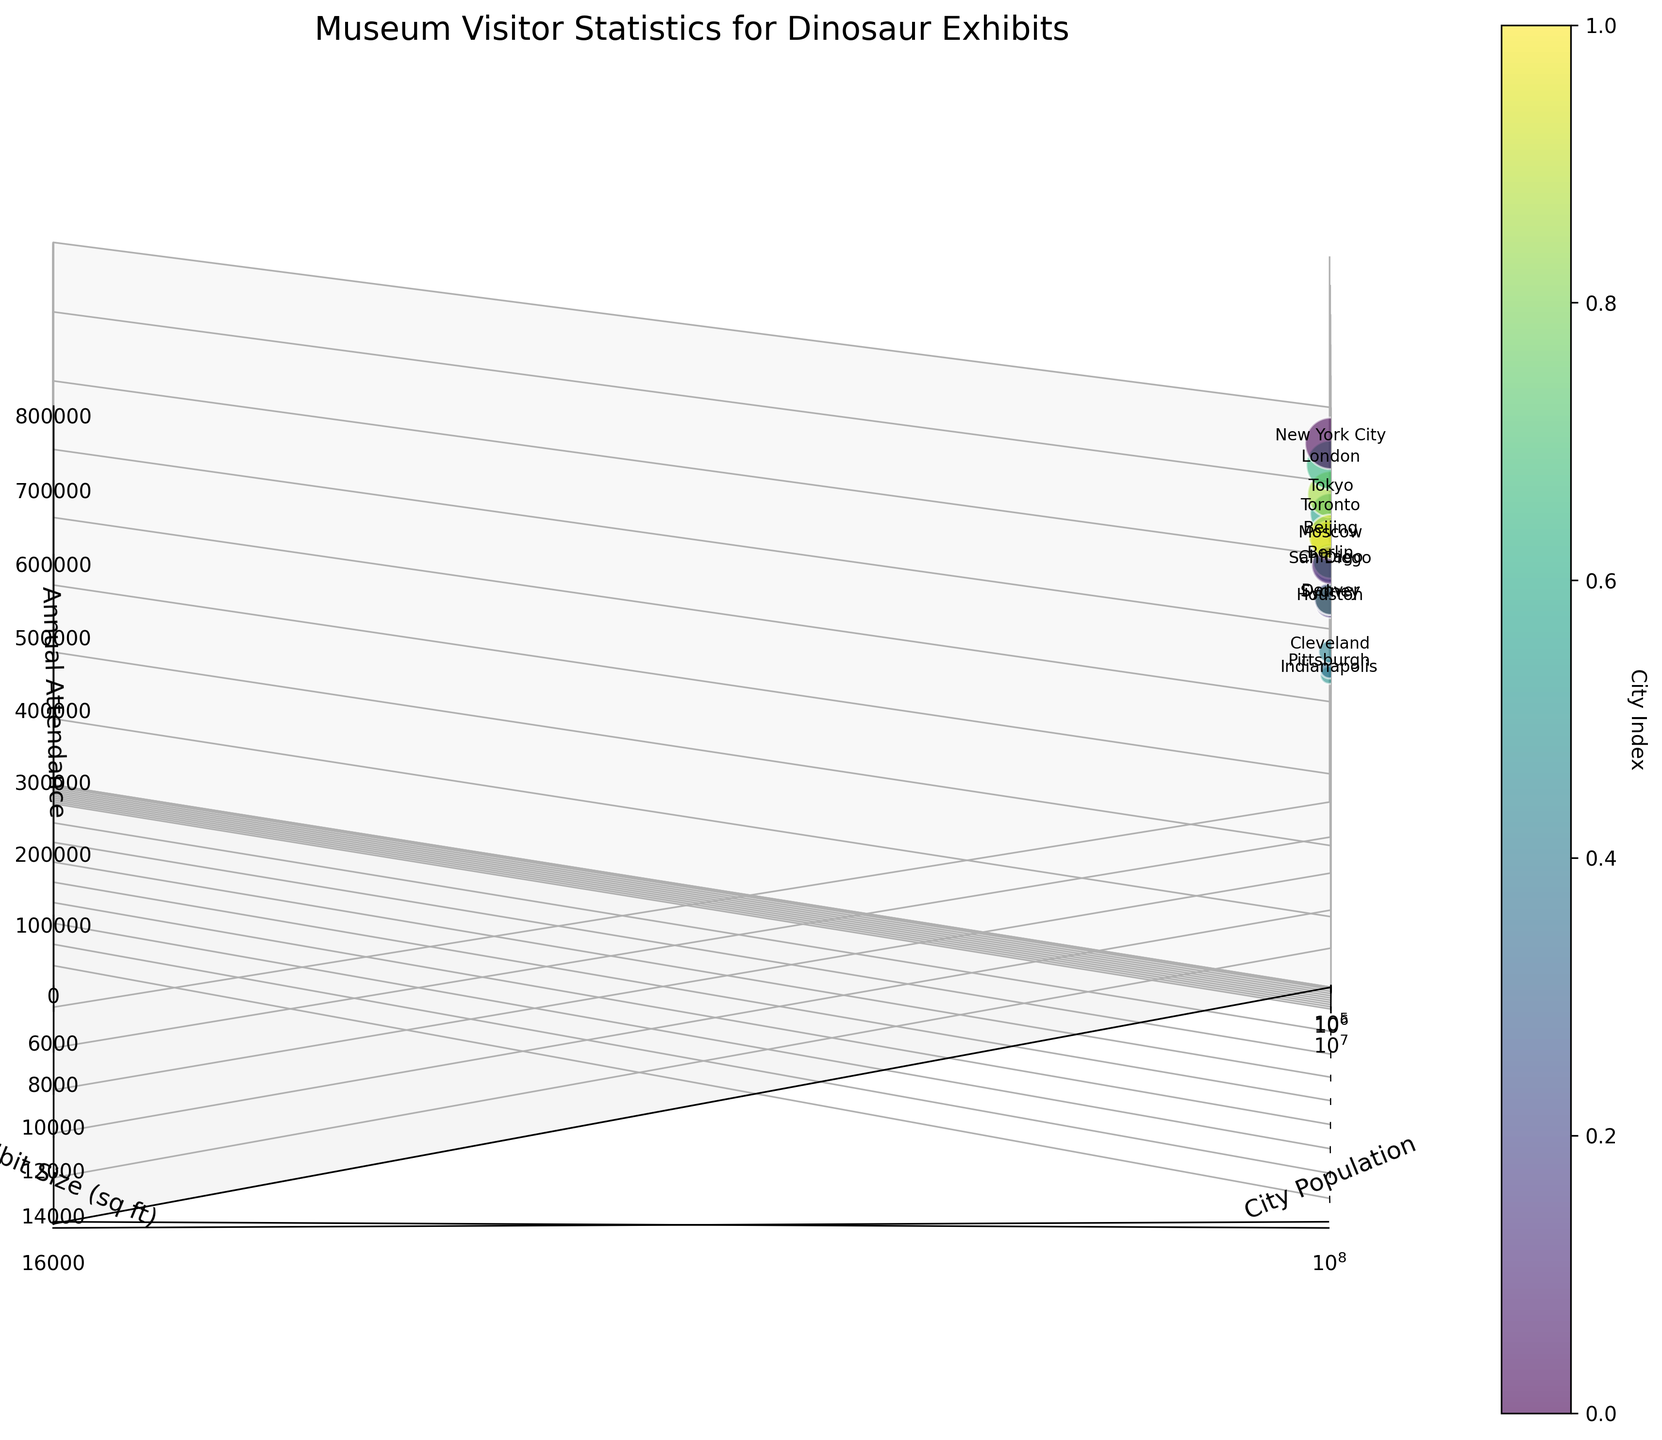What is the title of the chart? The title is located at the top center of the chart.
Answer: Museum Visitor Statistics for Dinosaur Exhibits How many cities are represented in the chart? The data points (bubbles) correspond to the number of cities, which can be counted. There are 15 cities listed in the data provided.
Answer: 15 Which city has the highest annual attendance? Look for the bubble with the highest 'z' value, and refer to the annotations to find the corresponding city.
Answer: New York City Which city has the smallest exhibit size? Find the bubble with the smallest value on the 'y' axis, and refer to the annotations to identify the city.
Answer: Indianapolis What is the range of population sizes included in the chart? Observe the 'x' axis to determine the minimum and maximum population values.
Answer: Approximately 302,000 to 21,542,000 Which city has a higher population: Tokyo or Berlin? Compare the 'x' values for the bubbles labeled Tokyo and Berlin.
Answer: Tokyo Calculate the average exhibit size of the museums. Sum the exhibit sizes and divide by the number of cities: (15000 + 12000 + 8000 + 10000 + 9000 + 6000 + 7000 + 5500 + 11000 + 14000 + 9500 + 8500 + 13000 + 12500 + 10500) / 15 = 10500
Answer: 10500 Which city has a similar exhibit size to Sydney? Find the 'y' value for Sydney and look for other bubbles with similar 'y' values, cross-referencing with annotations. Berlin has an exhibit size similar to Sydney.
Answer: Berlin Among the cities with exhibit sizes greater than 10,000 sq ft, which city has the lowest annual attendance? Filter the bubbles to those with 'y' values greater than 10,000 and find the one with the lowest 'z' value. This city is Toronto, which has annual attendance of 550,000.
Answer: Toronto Is there a general trend between city population and annual attendance? Observe the overall positioning of bubbles along the 'x' (population) and 'z' (attendance) axes to determine if there is a noticeable trend. Higher population cities tend to have higher annual attendance.
Answer: Yes 